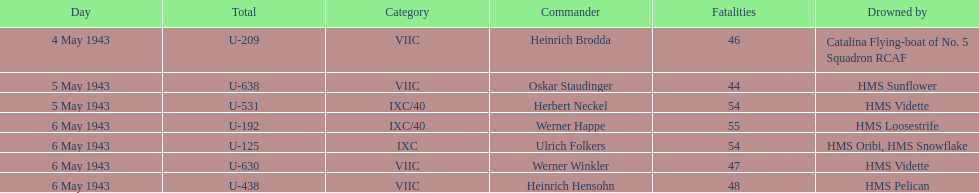Which u-boat was the first to sink U-209. 